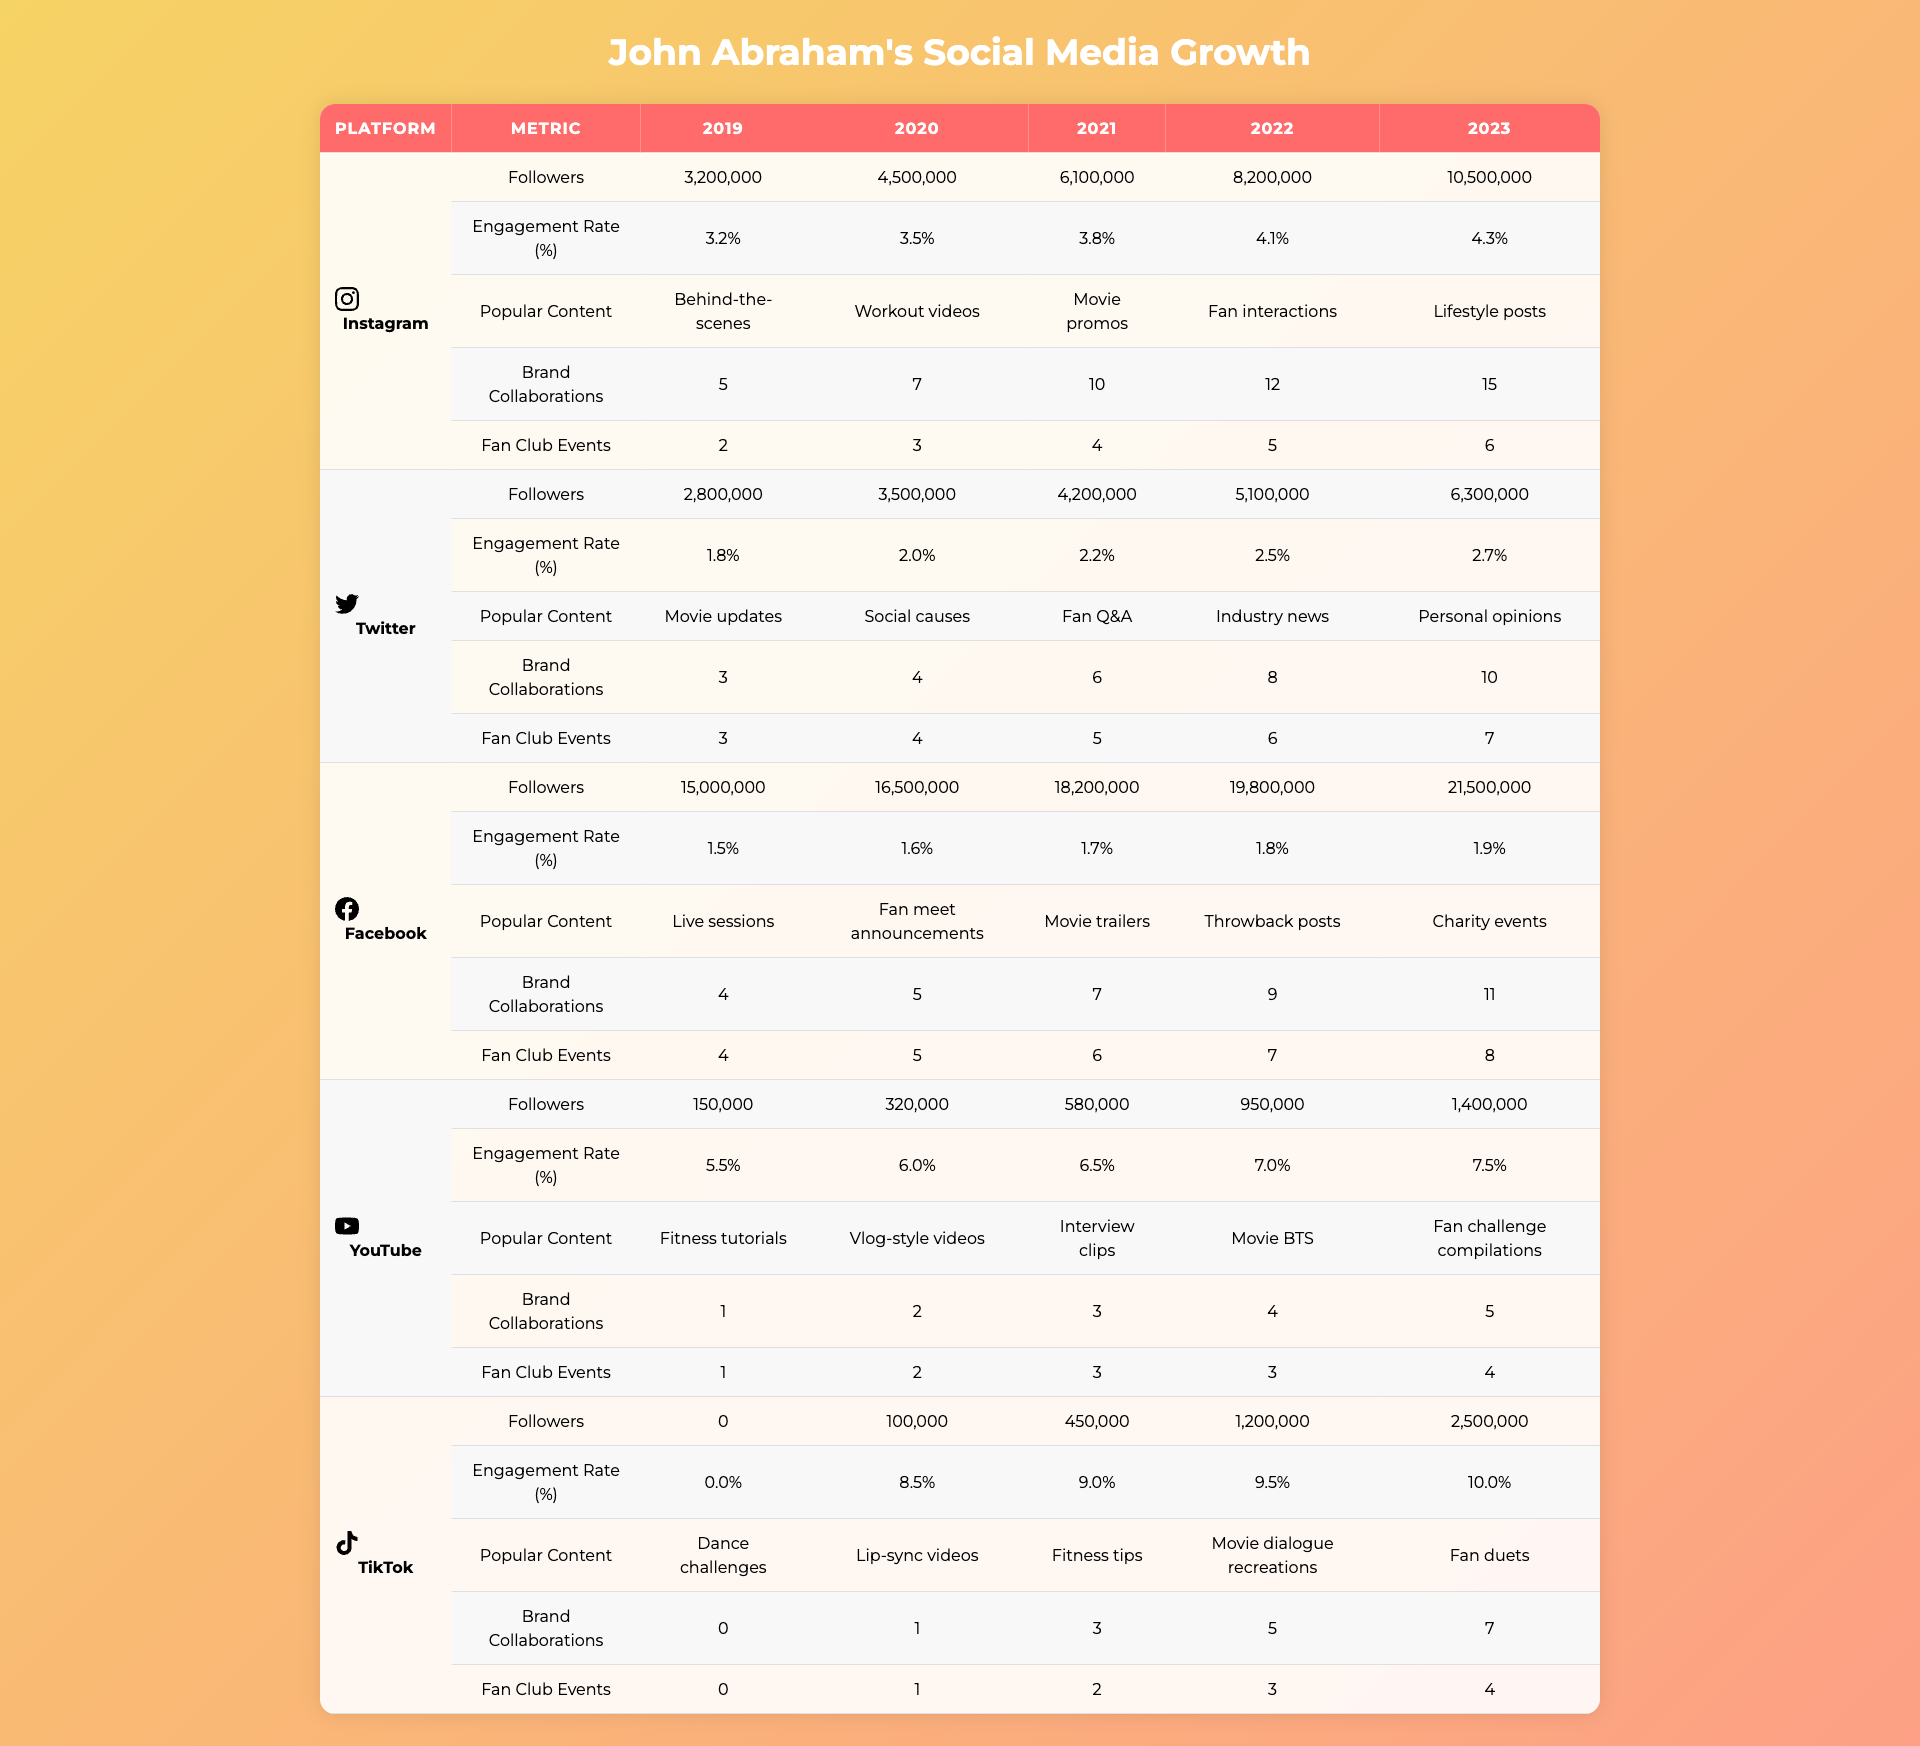What platform had the highest follower count in 2023? Looking at the follower counts in the year 2023 for each platform, Instagram has 10,500,000 followers, while the next highest is Facebook with 21,500,000 followers. Therefore, Facebook has the highest follower count in 2023.
Answer: Facebook Which platform showed the most significant follower growth from 2019 to 2023? To determine the growth, we can subtract the follower count in 2019 from that in 2023 for each platform. Instagram: 10,500,000 - 3,200,000 = 7,300,000; Twitter: 6,300,000 - 2,800,000 = 3,500,000; Facebook: 21,500,000 - 15,000,000 = 6,500,000; YouTube: 1,400,000 - 150,000 = 1,250,000; TikTok: 2,500,000 - 0 = 2,500,000. The highest growth is for Instagram.
Answer: Instagram What was the engagement rate on TikTok in 2022? Referring to the engagement rates for TikTok in 2022, it is listed as 9.5%.
Answer: 9.5% Did John Abraham see an increase in brand collaborations on YouTube every year? The data for YouTube shows brand collaborations as follows: 1, 2, 3, 4, 5 from 2019 to 2023 respectively. Each year shows an increase, confirming a consistent upward trend.
Answer: Yes What is the total number of fan club organized events across all platforms in 2023? To find the total events in 2023, we sum the values for each platform: Instagram (6), Twitter (7), Facebook (8), YouTube (4), TikTok (4). Total = 6 + 7 + 8 + 4 + 4 = 29.
Answer: 29 Which platform had the lowest engagement rate in 2020? By examining the engagement rates in 2020, Instagram has 3.5%, Twitter has 2.0%, Facebook has 1.6%, YouTube has 6.0%, and TikTok is not applicable (0%). Therefore, Facebook has the lowest engagement rate in 2020.
Answer: Facebook Calculate the average number of followers on Facebook from 2019 to 2023. The follower counts for Facebook are: 15,000,000, 16,500,000, 18,200,000, 19,800,000, and 21,500,000. To find the average, we sum these values (15,000,000 + 16,500,000 + 18,200,000 + 19,800,000 + 21,500,000 = 90,000,000) and divide by the number of years (5). The average is 90,000,000 / 5 = 18,000,000.
Answer: 18,000,000 In which year did TikTok see its highest growth in followers compared to the previous year? Observing the growth in followers for TikTok: 100,000 in 2020 (0 in 2019), resulting in 100,000; 450,000 in 2021 (100,000 in 2020), resulting in 350,000; 1,200,000 in 2022 (450,000 in 2021), resulting in 750,000; and 2,500,000 in 2023 (1,200,000 in 2022), resulting in 1,300,000. The highest growth was from 2022 to 2023 with an increase of 1,300,000 followers.
Answer: 2023 How many more brand collaborations did Instagram have compared to Twitter in 2023? In 2023, Instagram had 15 brand collaborations while Twitter had 10. The difference is 15 - 10 = 5.
Answer: 5 Which platform had the most popular content type of "Live sessions"? Looking at the most popular content types across platforms, "Live sessions" is specifically identified under Facebook.
Answer: Facebook 